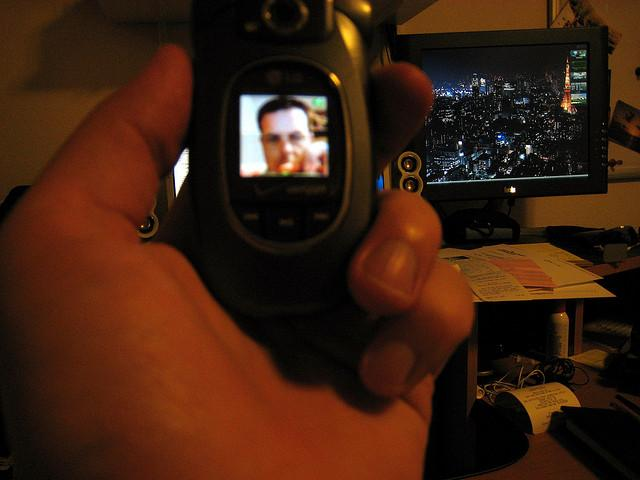What type of telephone does this person have? flip phone 